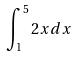Convert formula to latex. <formula><loc_0><loc_0><loc_500><loc_500>\int _ { 1 } ^ { 5 } 2 x d x</formula> 